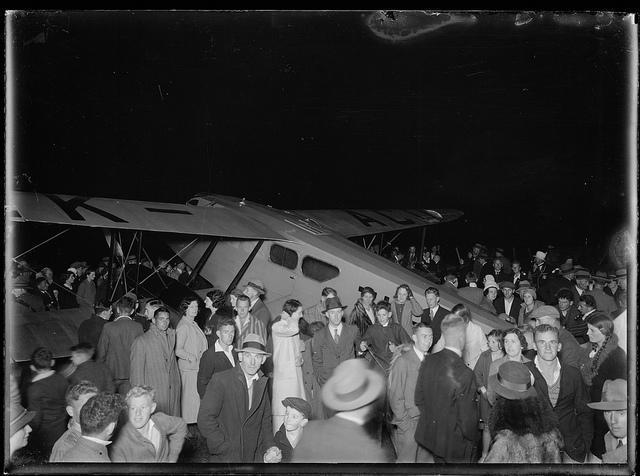How many people can be seen?
Give a very brief answer. 10. How many elephants are there?
Give a very brief answer. 0. 